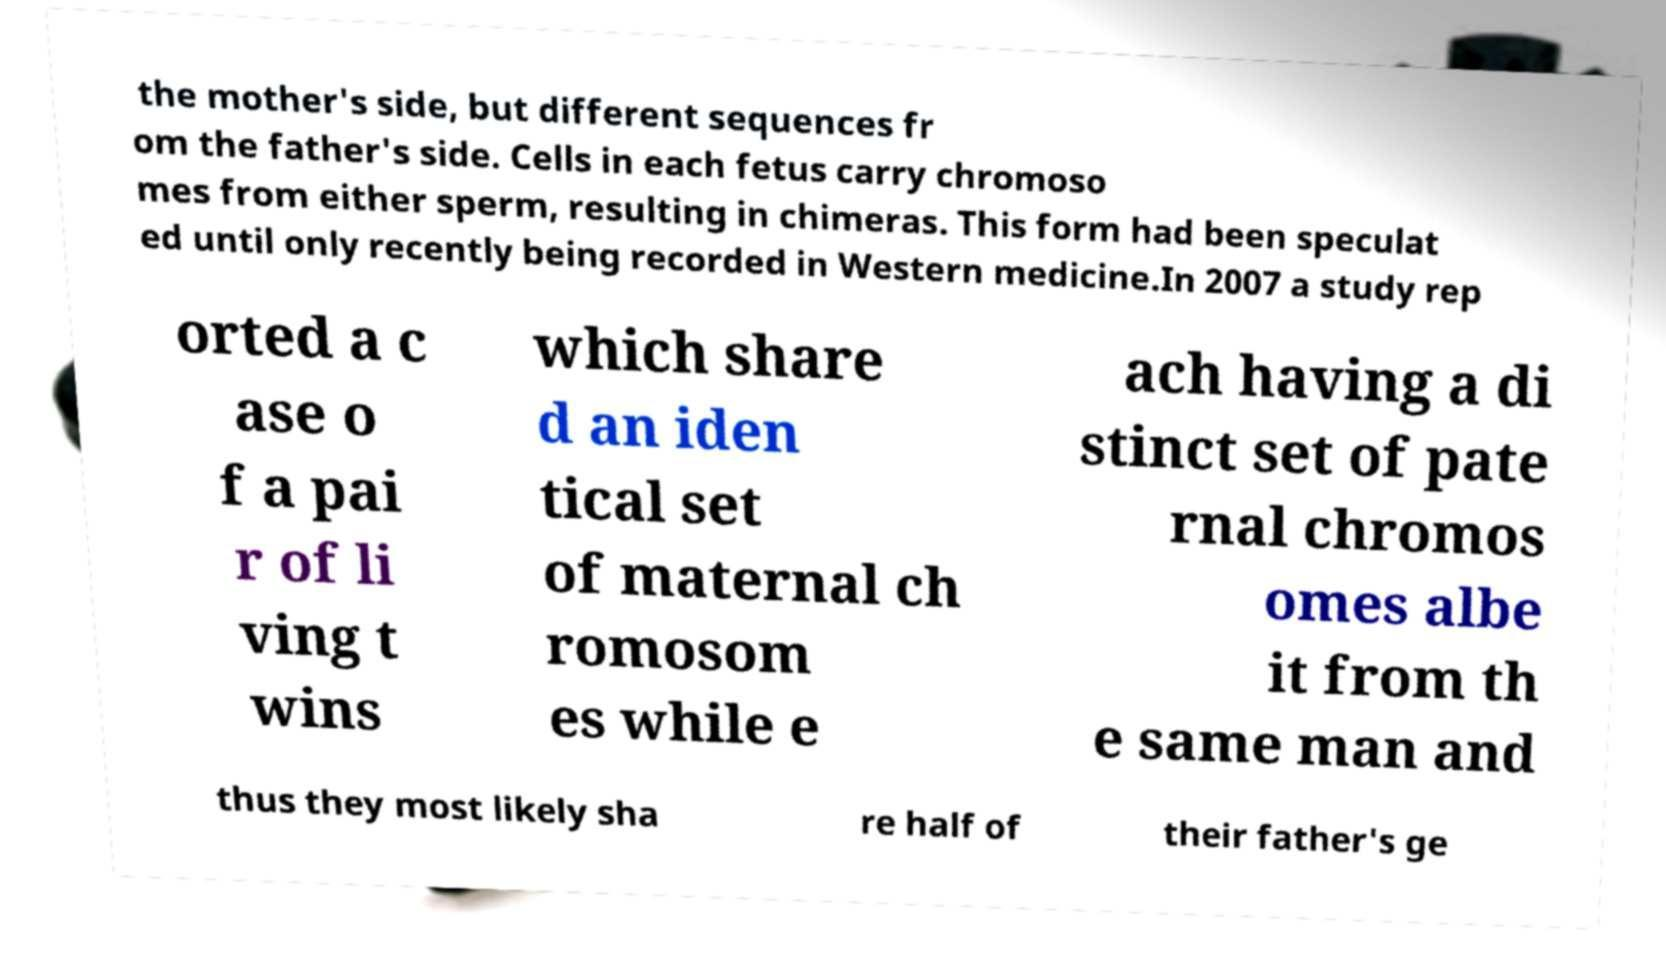There's text embedded in this image that I need extracted. Can you transcribe it verbatim? the mother's side, but different sequences fr om the father's side. Cells in each fetus carry chromoso mes from either sperm, resulting in chimeras. This form had been speculat ed until only recently being recorded in Western medicine.In 2007 a study rep orted a c ase o f a pai r of li ving t wins which share d an iden tical set of maternal ch romosom es while e ach having a di stinct set of pate rnal chromos omes albe it from th e same man and thus they most likely sha re half of their father's ge 